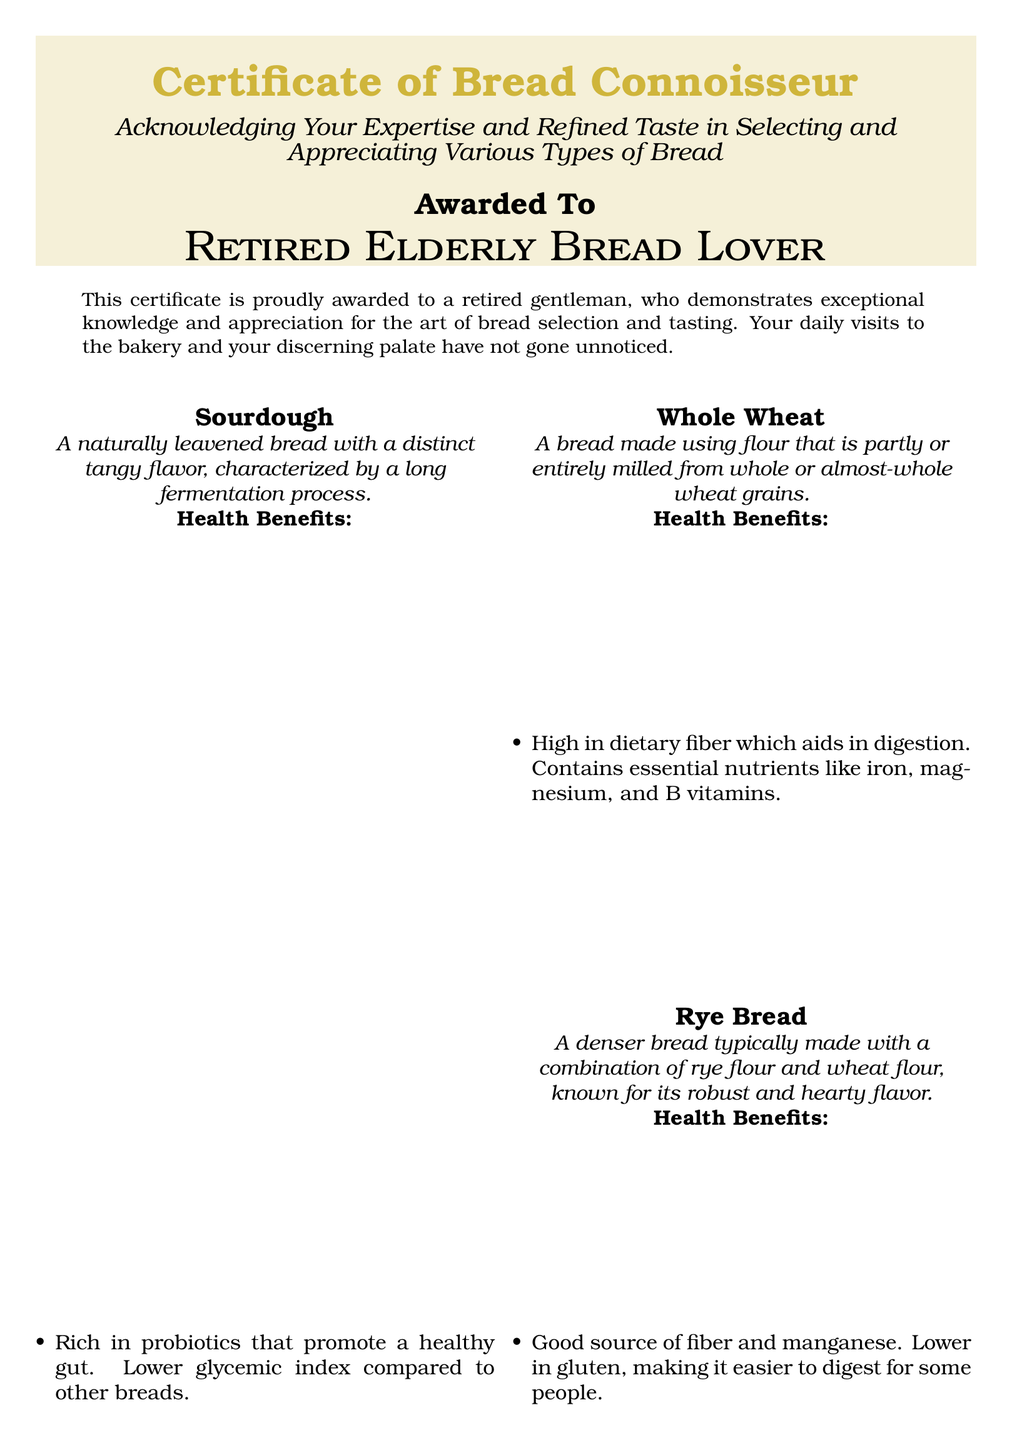What is the title of the certificate? The title of the certificate is prominently displayed at the top, acknowledging the recipient's expertise in bread selection.
Answer: Certificate of Bread Connoisseur Who is the certificate awarded to? The certificate specifies the individual's name, which is presented in a prominent font.
Answer: Retired Elderly Bread Lover What type of bread is known for its dense texture and hearty flavor? The document describes various types of bread and their characteristics, one of them is dense and hearty.
Answer: Rye Bread What are the health benefits of Sourdough? The document lists the health benefits of each type of bread, including its positive effects on digestive health.
Answer: Rich in probiotics that promote a healthy gut Which type of bread provides sustained energy? The description of the baguette mentions its complex carbohydrates that help in sustaining energy levels.
Answer: Baguette How many types of bread are mentioned in the document? The document categorizes the types of bread and presents them in distinct sections.
Answer: Four What is the name of the organization giving the award? The document includes a closing statement indicating the awarding organization, which is typically a bakery.
Answer: Bakery Name What nutritional component is highlighted in Whole Wheat bread? The document emphasizes a significant health benefit related to fiber content in Whole Wheat bread.
Answer: Dietary fiber What is the color scheme used in the certificate? The certificate's aesthetic is described by the colors utilized within its design for highlighting and backgrounds.
Answer: Old gold and light brown 